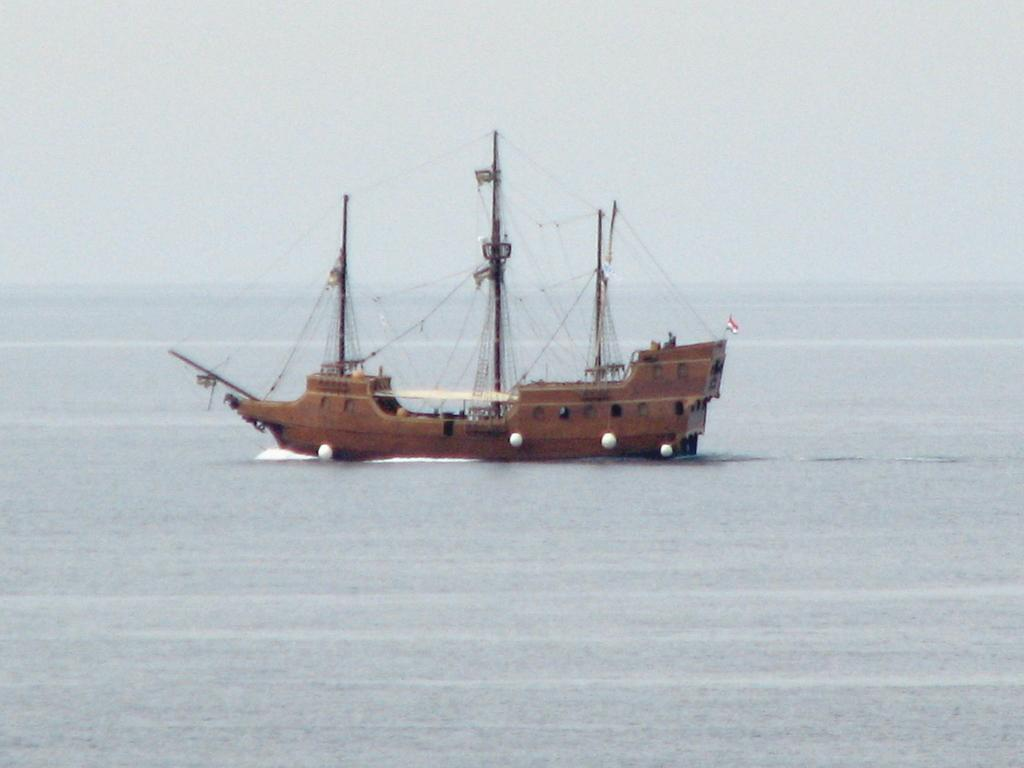What is the main subject of the image? The main subject of the image is a ship. Where is the ship located? The ship is on a sea. What is the position of the judge in the image? There is no judge present in the image; it features a ship on a sea. What is the weight of the position in the image? There is no position with a weight in the image; it features a ship on a sea. 